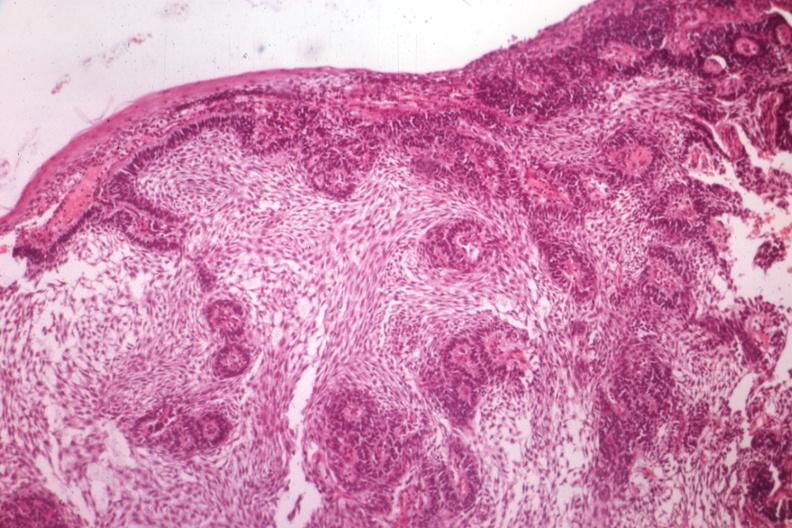s vessel present?
Answer the question using a single word or phrase. No 